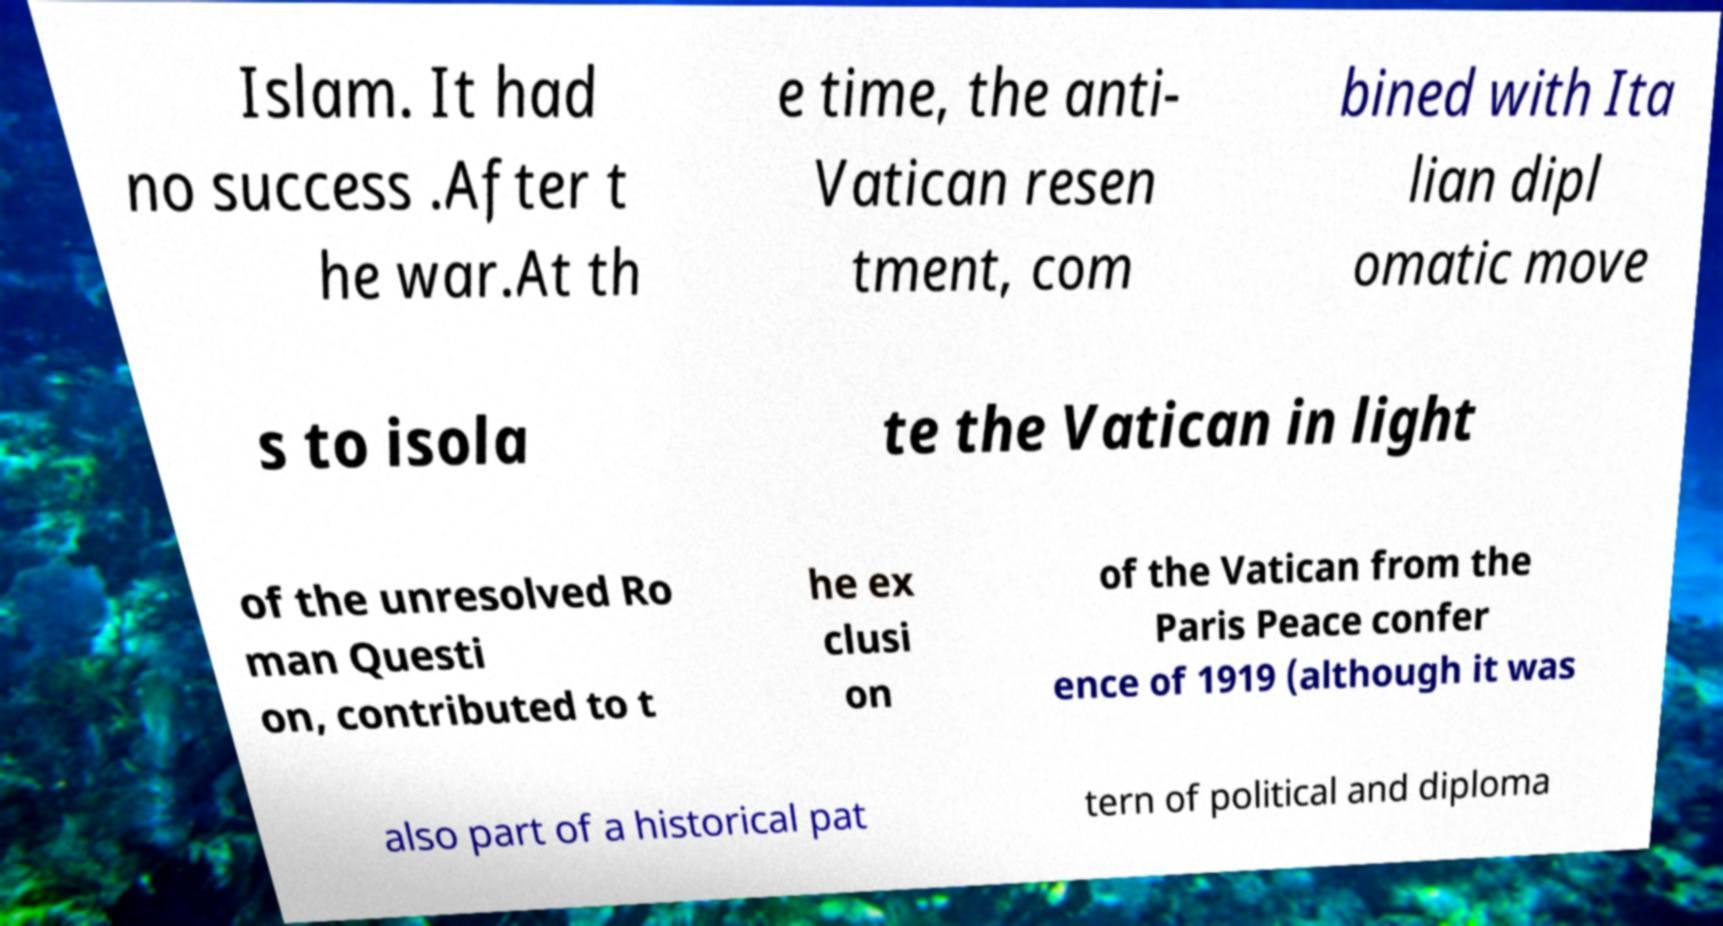Could you extract and type out the text from this image? Islam. It had no success .After t he war.At th e time, the anti- Vatican resen tment, com bined with Ita lian dipl omatic move s to isola te the Vatican in light of the unresolved Ro man Questi on, contributed to t he ex clusi on of the Vatican from the Paris Peace confer ence of 1919 (although it was also part of a historical pat tern of political and diploma 